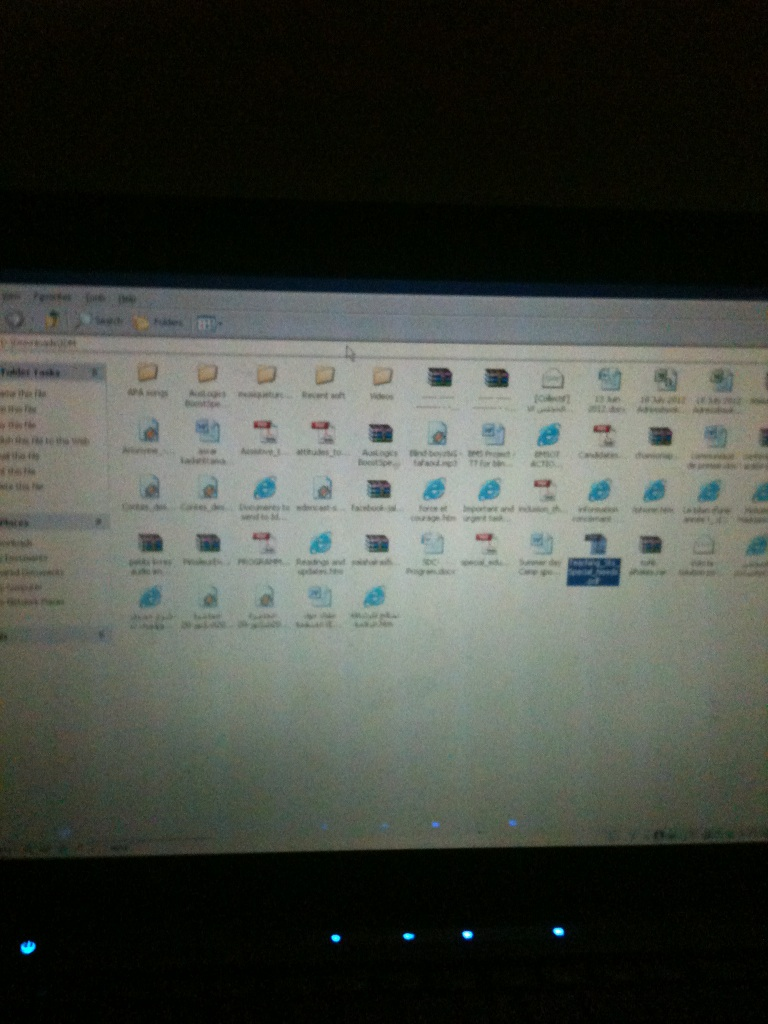Describe a realistic scenario where this folder would be particularly useful. This folder would be especially useful in a work-from-home situation where quick access to various documents and applications is necessary. For instance, if you are a student or professional working on multiple projects, having program installers, web shortcuts, and document files in one folder means you can easily switch between tasks, download necessary software, or quickly open ongoing projects. What would you add to this folder to increase its efficiency? To increase the folder's efficiency, I would add shortcut links to often-used folders such as 'Documents,' 'Downloads,' and any specialized project folders. Including a 'ReadMe' file with details about the folder's contents and a 'To-Do' list could also be helpful. Additionally, incorporating a backup script to automatically copy important files to an external drive or cloud storage ensures data safety and accessibility. 